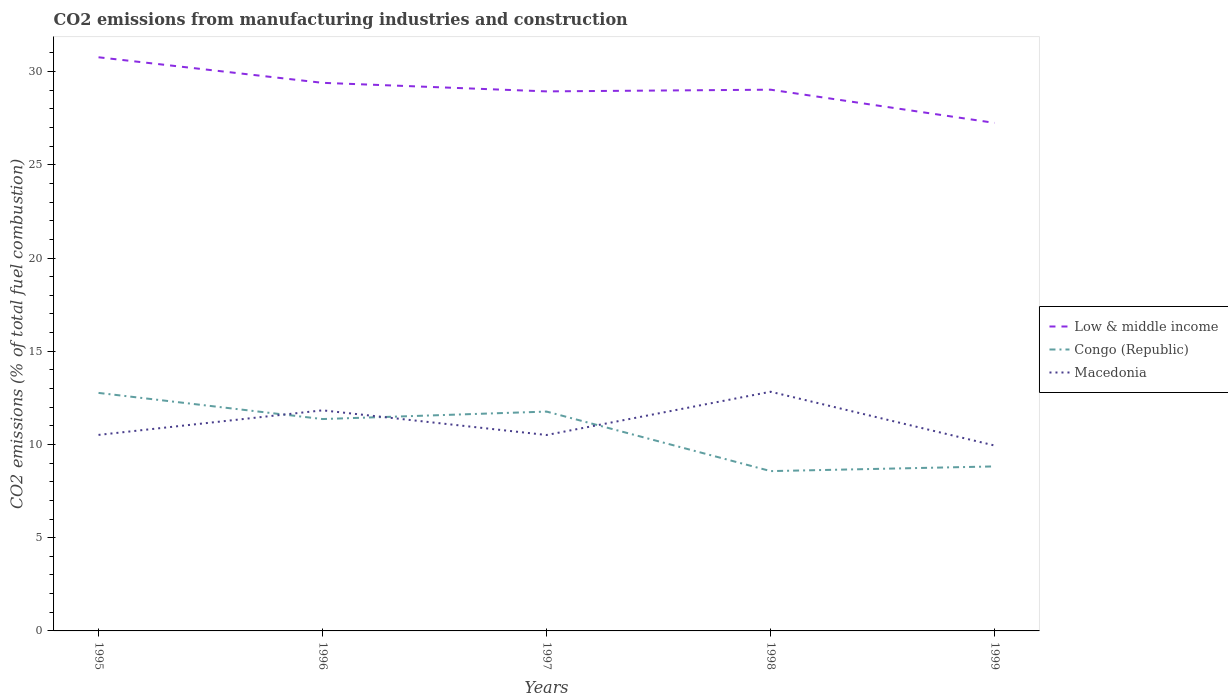How many different coloured lines are there?
Offer a very short reply. 3. Across all years, what is the maximum amount of CO2 emitted in Low & middle income?
Your answer should be very brief. 27.25. In which year was the amount of CO2 emitted in Congo (Republic) maximum?
Your answer should be compact. 1998. What is the total amount of CO2 emitted in Congo (Republic) in the graph?
Offer a very short reply. 1.4. What is the difference between the highest and the second highest amount of CO2 emitted in Low & middle income?
Make the answer very short. 3.52. What is the difference between the highest and the lowest amount of CO2 emitted in Low & middle income?
Offer a terse response. 2. Is the amount of CO2 emitted in Low & middle income strictly greater than the amount of CO2 emitted in Congo (Republic) over the years?
Your answer should be very brief. No. How many years are there in the graph?
Provide a succinct answer. 5. Where does the legend appear in the graph?
Provide a succinct answer. Center right. What is the title of the graph?
Keep it short and to the point. CO2 emissions from manufacturing industries and construction. Does "Luxembourg" appear as one of the legend labels in the graph?
Provide a succinct answer. No. What is the label or title of the X-axis?
Offer a very short reply. Years. What is the label or title of the Y-axis?
Offer a very short reply. CO2 emissions (% of total fuel combustion). What is the CO2 emissions (% of total fuel combustion) in Low & middle income in 1995?
Offer a terse response. 30.77. What is the CO2 emissions (% of total fuel combustion) in Congo (Republic) in 1995?
Your response must be concise. 12.77. What is the CO2 emissions (% of total fuel combustion) of Macedonia in 1995?
Give a very brief answer. 10.51. What is the CO2 emissions (% of total fuel combustion) of Low & middle income in 1996?
Your response must be concise. 29.4. What is the CO2 emissions (% of total fuel combustion) of Congo (Republic) in 1996?
Your answer should be very brief. 11.36. What is the CO2 emissions (% of total fuel combustion) in Macedonia in 1996?
Offer a terse response. 11.83. What is the CO2 emissions (% of total fuel combustion) of Low & middle income in 1997?
Offer a very short reply. 28.94. What is the CO2 emissions (% of total fuel combustion) in Congo (Republic) in 1997?
Make the answer very short. 11.76. What is the CO2 emissions (% of total fuel combustion) in Macedonia in 1997?
Your answer should be very brief. 10.51. What is the CO2 emissions (% of total fuel combustion) in Low & middle income in 1998?
Ensure brevity in your answer.  29.03. What is the CO2 emissions (% of total fuel combustion) in Congo (Republic) in 1998?
Your answer should be very brief. 8.57. What is the CO2 emissions (% of total fuel combustion) in Macedonia in 1998?
Your answer should be compact. 12.83. What is the CO2 emissions (% of total fuel combustion) of Low & middle income in 1999?
Keep it short and to the point. 27.25. What is the CO2 emissions (% of total fuel combustion) of Congo (Republic) in 1999?
Your answer should be very brief. 8.82. What is the CO2 emissions (% of total fuel combustion) of Macedonia in 1999?
Give a very brief answer. 9.94. Across all years, what is the maximum CO2 emissions (% of total fuel combustion) in Low & middle income?
Your answer should be very brief. 30.77. Across all years, what is the maximum CO2 emissions (% of total fuel combustion) in Congo (Republic)?
Your response must be concise. 12.77. Across all years, what is the maximum CO2 emissions (% of total fuel combustion) of Macedonia?
Make the answer very short. 12.83. Across all years, what is the minimum CO2 emissions (% of total fuel combustion) of Low & middle income?
Offer a very short reply. 27.25. Across all years, what is the minimum CO2 emissions (% of total fuel combustion) of Congo (Republic)?
Ensure brevity in your answer.  8.57. Across all years, what is the minimum CO2 emissions (% of total fuel combustion) in Macedonia?
Make the answer very short. 9.94. What is the total CO2 emissions (% of total fuel combustion) in Low & middle income in the graph?
Provide a short and direct response. 145.38. What is the total CO2 emissions (% of total fuel combustion) in Congo (Republic) in the graph?
Your answer should be very brief. 53.29. What is the total CO2 emissions (% of total fuel combustion) of Macedonia in the graph?
Your answer should be compact. 55.62. What is the difference between the CO2 emissions (% of total fuel combustion) in Low & middle income in 1995 and that in 1996?
Give a very brief answer. 1.37. What is the difference between the CO2 emissions (% of total fuel combustion) of Congo (Republic) in 1995 and that in 1996?
Make the answer very short. 1.4. What is the difference between the CO2 emissions (% of total fuel combustion) of Macedonia in 1995 and that in 1996?
Offer a terse response. -1.32. What is the difference between the CO2 emissions (% of total fuel combustion) of Low & middle income in 1995 and that in 1997?
Your answer should be very brief. 1.83. What is the difference between the CO2 emissions (% of total fuel combustion) in Macedonia in 1995 and that in 1997?
Give a very brief answer. 0.01. What is the difference between the CO2 emissions (% of total fuel combustion) in Low & middle income in 1995 and that in 1998?
Your answer should be very brief. 1.74. What is the difference between the CO2 emissions (% of total fuel combustion) in Congo (Republic) in 1995 and that in 1998?
Offer a very short reply. 4.19. What is the difference between the CO2 emissions (% of total fuel combustion) of Macedonia in 1995 and that in 1998?
Provide a succinct answer. -2.32. What is the difference between the CO2 emissions (% of total fuel combustion) in Low & middle income in 1995 and that in 1999?
Your answer should be compact. 3.52. What is the difference between the CO2 emissions (% of total fuel combustion) of Congo (Republic) in 1995 and that in 1999?
Ensure brevity in your answer.  3.94. What is the difference between the CO2 emissions (% of total fuel combustion) of Macedonia in 1995 and that in 1999?
Your answer should be compact. 0.57. What is the difference between the CO2 emissions (% of total fuel combustion) of Low & middle income in 1996 and that in 1997?
Keep it short and to the point. 0.46. What is the difference between the CO2 emissions (% of total fuel combustion) in Congo (Republic) in 1996 and that in 1997?
Make the answer very short. -0.4. What is the difference between the CO2 emissions (% of total fuel combustion) of Macedonia in 1996 and that in 1997?
Provide a short and direct response. 1.32. What is the difference between the CO2 emissions (% of total fuel combustion) in Low & middle income in 1996 and that in 1998?
Your answer should be very brief. 0.37. What is the difference between the CO2 emissions (% of total fuel combustion) in Congo (Republic) in 1996 and that in 1998?
Your answer should be very brief. 2.79. What is the difference between the CO2 emissions (% of total fuel combustion) in Macedonia in 1996 and that in 1998?
Your answer should be compact. -1. What is the difference between the CO2 emissions (% of total fuel combustion) of Low & middle income in 1996 and that in 1999?
Your answer should be compact. 2.15. What is the difference between the CO2 emissions (% of total fuel combustion) in Congo (Republic) in 1996 and that in 1999?
Offer a terse response. 2.54. What is the difference between the CO2 emissions (% of total fuel combustion) in Macedonia in 1996 and that in 1999?
Your response must be concise. 1.89. What is the difference between the CO2 emissions (% of total fuel combustion) in Low & middle income in 1997 and that in 1998?
Ensure brevity in your answer.  -0.09. What is the difference between the CO2 emissions (% of total fuel combustion) of Congo (Republic) in 1997 and that in 1998?
Offer a very short reply. 3.19. What is the difference between the CO2 emissions (% of total fuel combustion) of Macedonia in 1997 and that in 1998?
Make the answer very short. -2.32. What is the difference between the CO2 emissions (% of total fuel combustion) in Low & middle income in 1997 and that in 1999?
Offer a terse response. 1.69. What is the difference between the CO2 emissions (% of total fuel combustion) in Congo (Republic) in 1997 and that in 1999?
Your answer should be very brief. 2.94. What is the difference between the CO2 emissions (% of total fuel combustion) of Macedonia in 1997 and that in 1999?
Your response must be concise. 0.57. What is the difference between the CO2 emissions (% of total fuel combustion) of Low & middle income in 1998 and that in 1999?
Provide a short and direct response. 1.78. What is the difference between the CO2 emissions (% of total fuel combustion) in Congo (Republic) in 1998 and that in 1999?
Ensure brevity in your answer.  -0.25. What is the difference between the CO2 emissions (% of total fuel combustion) of Macedonia in 1998 and that in 1999?
Your answer should be very brief. 2.89. What is the difference between the CO2 emissions (% of total fuel combustion) of Low & middle income in 1995 and the CO2 emissions (% of total fuel combustion) of Congo (Republic) in 1996?
Make the answer very short. 19.4. What is the difference between the CO2 emissions (% of total fuel combustion) in Low & middle income in 1995 and the CO2 emissions (% of total fuel combustion) in Macedonia in 1996?
Your answer should be very brief. 18.94. What is the difference between the CO2 emissions (% of total fuel combustion) in Congo (Republic) in 1995 and the CO2 emissions (% of total fuel combustion) in Macedonia in 1996?
Make the answer very short. 0.93. What is the difference between the CO2 emissions (% of total fuel combustion) of Low & middle income in 1995 and the CO2 emissions (% of total fuel combustion) of Congo (Republic) in 1997?
Offer a terse response. 19. What is the difference between the CO2 emissions (% of total fuel combustion) in Low & middle income in 1995 and the CO2 emissions (% of total fuel combustion) in Macedonia in 1997?
Your answer should be very brief. 20.26. What is the difference between the CO2 emissions (% of total fuel combustion) of Congo (Republic) in 1995 and the CO2 emissions (% of total fuel combustion) of Macedonia in 1997?
Your answer should be compact. 2.26. What is the difference between the CO2 emissions (% of total fuel combustion) of Low & middle income in 1995 and the CO2 emissions (% of total fuel combustion) of Congo (Republic) in 1998?
Provide a succinct answer. 22.2. What is the difference between the CO2 emissions (% of total fuel combustion) of Low & middle income in 1995 and the CO2 emissions (% of total fuel combustion) of Macedonia in 1998?
Offer a terse response. 17.94. What is the difference between the CO2 emissions (% of total fuel combustion) of Congo (Republic) in 1995 and the CO2 emissions (% of total fuel combustion) of Macedonia in 1998?
Your answer should be compact. -0.06. What is the difference between the CO2 emissions (% of total fuel combustion) in Low & middle income in 1995 and the CO2 emissions (% of total fuel combustion) in Congo (Republic) in 1999?
Your answer should be very brief. 21.94. What is the difference between the CO2 emissions (% of total fuel combustion) in Low & middle income in 1995 and the CO2 emissions (% of total fuel combustion) in Macedonia in 1999?
Offer a very short reply. 20.83. What is the difference between the CO2 emissions (% of total fuel combustion) of Congo (Republic) in 1995 and the CO2 emissions (% of total fuel combustion) of Macedonia in 1999?
Your answer should be compact. 2.82. What is the difference between the CO2 emissions (% of total fuel combustion) of Low & middle income in 1996 and the CO2 emissions (% of total fuel combustion) of Congo (Republic) in 1997?
Give a very brief answer. 17.63. What is the difference between the CO2 emissions (% of total fuel combustion) of Low & middle income in 1996 and the CO2 emissions (% of total fuel combustion) of Macedonia in 1997?
Your answer should be very brief. 18.89. What is the difference between the CO2 emissions (% of total fuel combustion) of Congo (Republic) in 1996 and the CO2 emissions (% of total fuel combustion) of Macedonia in 1997?
Offer a terse response. 0.86. What is the difference between the CO2 emissions (% of total fuel combustion) of Low & middle income in 1996 and the CO2 emissions (% of total fuel combustion) of Congo (Republic) in 1998?
Your response must be concise. 20.83. What is the difference between the CO2 emissions (% of total fuel combustion) of Low & middle income in 1996 and the CO2 emissions (% of total fuel combustion) of Macedonia in 1998?
Make the answer very short. 16.57. What is the difference between the CO2 emissions (% of total fuel combustion) in Congo (Republic) in 1996 and the CO2 emissions (% of total fuel combustion) in Macedonia in 1998?
Provide a succinct answer. -1.47. What is the difference between the CO2 emissions (% of total fuel combustion) in Low & middle income in 1996 and the CO2 emissions (% of total fuel combustion) in Congo (Republic) in 1999?
Your answer should be very brief. 20.57. What is the difference between the CO2 emissions (% of total fuel combustion) of Low & middle income in 1996 and the CO2 emissions (% of total fuel combustion) of Macedonia in 1999?
Provide a short and direct response. 19.45. What is the difference between the CO2 emissions (% of total fuel combustion) in Congo (Republic) in 1996 and the CO2 emissions (% of total fuel combustion) in Macedonia in 1999?
Your answer should be very brief. 1.42. What is the difference between the CO2 emissions (% of total fuel combustion) of Low & middle income in 1997 and the CO2 emissions (% of total fuel combustion) of Congo (Republic) in 1998?
Give a very brief answer. 20.37. What is the difference between the CO2 emissions (% of total fuel combustion) of Low & middle income in 1997 and the CO2 emissions (% of total fuel combustion) of Macedonia in 1998?
Keep it short and to the point. 16.11. What is the difference between the CO2 emissions (% of total fuel combustion) in Congo (Republic) in 1997 and the CO2 emissions (% of total fuel combustion) in Macedonia in 1998?
Your answer should be very brief. -1.06. What is the difference between the CO2 emissions (% of total fuel combustion) in Low & middle income in 1997 and the CO2 emissions (% of total fuel combustion) in Congo (Republic) in 1999?
Ensure brevity in your answer.  20.11. What is the difference between the CO2 emissions (% of total fuel combustion) in Low & middle income in 1997 and the CO2 emissions (% of total fuel combustion) in Macedonia in 1999?
Provide a succinct answer. 19. What is the difference between the CO2 emissions (% of total fuel combustion) of Congo (Republic) in 1997 and the CO2 emissions (% of total fuel combustion) of Macedonia in 1999?
Offer a very short reply. 1.82. What is the difference between the CO2 emissions (% of total fuel combustion) of Low & middle income in 1998 and the CO2 emissions (% of total fuel combustion) of Congo (Republic) in 1999?
Provide a short and direct response. 20.21. What is the difference between the CO2 emissions (% of total fuel combustion) of Low & middle income in 1998 and the CO2 emissions (% of total fuel combustion) of Macedonia in 1999?
Provide a short and direct response. 19.09. What is the difference between the CO2 emissions (% of total fuel combustion) in Congo (Republic) in 1998 and the CO2 emissions (% of total fuel combustion) in Macedonia in 1999?
Give a very brief answer. -1.37. What is the average CO2 emissions (% of total fuel combustion) of Low & middle income per year?
Offer a terse response. 29.08. What is the average CO2 emissions (% of total fuel combustion) in Congo (Republic) per year?
Offer a very short reply. 10.66. What is the average CO2 emissions (% of total fuel combustion) in Macedonia per year?
Provide a succinct answer. 11.12. In the year 1995, what is the difference between the CO2 emissions (% of total fuel combustion) in Low & middle income and CO2 emissions (% of total fuel combustion) in Congo (Republic)?
Give a very brief answer. 18. In the year 1995, what is the difference between the CO2 emissions (% of total fuel combustion) in Low & middle income and CO2 emissions (% of total fuel combustion) in Macedonia?
Your response must be concise. 20.25. In the year 1995, what is the difference between the CO2 emissions (% of total fuel combustion) of Congo (Republic) and CO2 emissions (% of total fuel combustion) of Macedonia?
Make the answer very short. 2.25. In the year 1996, what is the difference between the CO2 emissions (% of total fuel combustion) of Low & middle income and CO2 emissions (% of total fuel combustion) of Congo (Republic)?
Your answer should be compact. 18.03. In the year 1996, what is the difference between the CO2 emissions (% of total fuel combustion) of Low & middle income and CO2 emissions (% of total fuel combustion) of Macedonia?
Ensure brevity in your answer.  17.57. In the year 1996, what is the difference between the CO2 emissions (% of total fuel combustion) of Congo (Republic) and CO2 emissions (% of total fuel combustion) of Macedonia?
Your answer should be compact. -0.47. In the year 1997, what is the difference between the CO2 emissions (% of total fuel combustion) in Low & middle income and CO2 emissions (% of total fuel combustion) in Congo (Republic)?
Offer a terse response. 17.17. In the year 1997, what is the difference between the CO2 emissions (% of total fuel combustion) in Low & middle income and CO2 emissions (% of total fuel combustion) in Macedonia?
Keep it short and to the point. 18.43. In the year 1997, what is the difference between the CO2 emissions (% of total fuel combustion) in Congo (Republic) and CO2 emissions (% of total fuel combustion) in Macedonia?
Offer a very short reply. 1.26. In the year 1998, what is the difference between the CO2 emissions (% of total fuel combustion) in Low & middle income and CO2 emissions (% of total fuel combustion) in Congo (Republic)?
Make the answer very short. 20.46. In the year 1998, what is the difference between the CO2 emissions (% of total fuel combustion) in Low & middle income and CO2 emissions (% of total fuel combustion) in Macedonia?
Ensure brevity in your answer.  16.2. In the year 1998, what is the difference between the CO2 emissions (% of total fuel combustion) in Congo (Republic) and CO2 emissions (% of total fuel combustion) in Macedonia?
Provide a succinct answer. -4.26. In the year 1999, what is the difference between the CO2 emissions (% of total fuel combustion) of Low & middle income and CO2 emissions (% of total fuel combustion) of Congo (Republic)?
Provide a succinct answer. 18.42. In the year 1999, what is the difference between the CO2 emissions (% of total fuel combustion) in Low & middle income and CO2 emissions (% of total fuel combustion) in Macedonia?
Keep it short and to the point. 17.3. In the year 1999, what is the difference between the CO2 emissions (% of total fuel combustion) in Congo (Republic) and CO2 emissions (% of total fuel combustion) in Macedonia?
Your answer should be very brief. -1.12. What is the ratio of the CO2 emissions (% of total fuel combustion) of Low & middle income in 1995 to that in 1996?
Offer a very short reply. 1.05. What is the ratio of the CO2 emissions (% of total fuel combustion) in Congo (Republic) in 1995 to that in 1996?
Your answer should be very brief. 1.12. What is the ratio of the CO2 emissions (% of total fuel combustion) of Macedonia in 1995 to that in 1996?
Make the answer very short. 0.89. What is the ratio of the CO2 emissions (% of total fuel combustion) in Low & middle income in 1995 to that in 1997?
Make the answer very short. 1.06. What is the ratio of the CO2 emissions (% of total fuel combustion) of Congo (Republic) in 1995 to that in 1997?
Provide a succinct answer. 1.09. What is the ratio of the CO2 emissions (% of total fuel combustion) in Macedonia in 1995 to that in 1997?
Ensure brevity in your answer.  1. What is the ratio of the CO2 emissions (% of total fuel combustion) in Low & middle income in 1995 to that in 1998?
Provide a succinct answer. 1.06. What is the ratio of the CO2 emissions (% of total fuel combustion) of Congo (Republic) in 1995 to that in 1998?
Ensure brevity in your answer.  1.49. What is the ratio of the CO2 emissions (% of total fuel combustion) of Macedonia in 1995 to that in 1998?
Your answer should be compact. 0.82. What is the ratio of the CO2 emissions (% of total fuel combustion) of Low & middle income in 1995 to that in 1999?
Your response must be concise. 1.13. What is the ratio of the CO2 emissions (% of total fuel combustion) in Congo (Republic) in 1995 to that in 1999?
Provide a succinct answer. 1.45. What is the ratio of the CO2 emissions (% of total fuel combustion) of Macedonia in 1995 to that in 1999?
Give a very brief answer. 1.06. What is the ratio of the CO2 emissions (% of total fuel combustion) in Low & middle income in 1996 to that in 1997?
Your answer should be very brief. 1.02. What is the ratio of the CO2 emissions (% of total fuel combustion) in Congo (Republic) in 1996 to that in 1997?
Ensure brevity in your answer.  0.97. What is the ratio of the CO2 emissions (% of total fuel combustion) in Macedonia in 1996 to that in 1997?
Your answer should be compact. 1.13. What is the ratio of the CO2 emissions (% of total fuel combustion) of Low & middle income in 1996 to that in 1998?
Your answer should be compact. 1.01. What is the ratio of the CO2 emissions (% of total fuel combustion) in Congo (Republic) in 1996 to that in 1998?
Offer a very short reply. 1.33. What is the ratio of the CO2 emissions (% of total fuel combustion) in Macedonia in 1996 to that in 1998?
Your answer should be very brief. 0.92. What is the ratio of the CO2 emissions (% of total fuel combustion) of Low & middle income in 1996 to that in 1999?
Make the answer very short. 1.08. What is the ratio of the CO2 emissions (% of total fuel combustion) of Congo (Republic) in 1996 to that in 1999?
Offer a terse response. 1.29. What is the ratio of the CO2 emissions (% of total fuel combustion) in Macedonia in 1996 to that in 1999?
Provide a succinct answer. 1.19. What is the ratio of the CO2 emissions (% of total fuel combustion) of Low & middle income in 1997 to that in 1998?
Provide a short and direct response. 1. What is the ratio of the CO2 emissions (% of total fuel combustion) of Congo (Republic) in 1997 to that in 1998?
Your answer should be very brief. 1.37. What is the ratio of the CO2 emissions (% of total fuel combustion) of Macedonia in 1997 to that in 1998?
Provide a short and direct response. 0.82. What is the ratio of the CO2 emissions (% of total fuel combustion) of Low & middle income in 1997 to that in 1999?
Make the answer very short. 1.06. What is the ratio of the CO2 emissions (% of total fuel combustion) of Macedonia in 1997 to that in 1999?
Provide a short and direct response. 1.06. What is the ratio of the CO2 emissions (% of total fuel combustion) in Low & middle income in 1998 to that in 1999?
Provide a short and direct response. 1.07. What is the ratio of the CO2 emissions (% of total fuel combustion) in Congo (Republic) in 1998 to that in 1999?
Your answer should be very brief. 0.97. What is the ratio of the CO2 emissions (% of total fuel combustion) in Macedonia in 1998 to that in 1999?
Make the answer very short. 1.29. What is the difference between the highest and the second highest CO2 emissions (% of total fuel combustion) in Low & middle income?
Your answer should be compact. 1.37. What is the difference between the highest and the second highest CO2 emissions (% of total fuel combustion) in Congo (Republic)?
Provide a succinct answer. 1. What is the difference between the highest and the second highest CO2 emissions (% of total fuel combustion) in Macedonia?
Your answer should be very brief. 1. What is the difference between the highest and the lowest CO2 emissions (% of total fuel combustion) of Low & middle income?
Your answer should be very brief. 3.52. What is the difference between the highest and the lowest CO2 emissions (% of total fuel combustion) in Congo (Republic)?
Offer a terse response. 4.19. What is the difference between the highest and the lowest CO2 emissions (% of total fuel combustion) in Macedonia?
Ensure brevity in your answer.  2.89. 